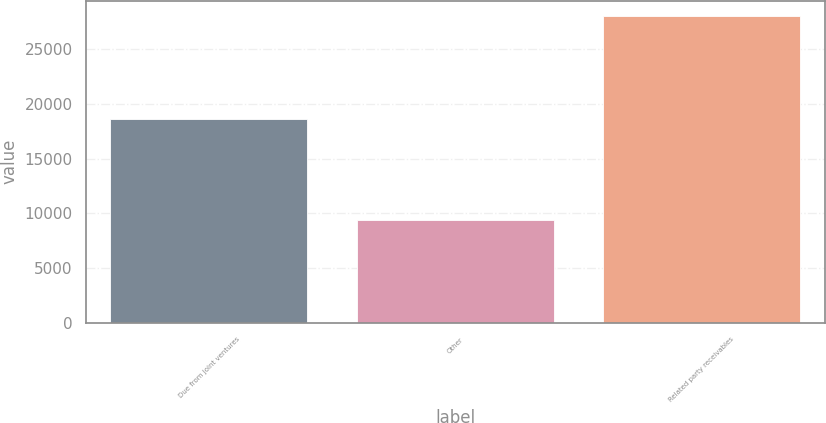Convert chart. <chart><loc_0><loc_0><loc_500><loc_500><bar_chart><fcel>Due from joint ventures<fcel>Other<fcel>Related party receivables<nl><fcel>18655<fcel>9378<fcel>28033<nl></chart> 